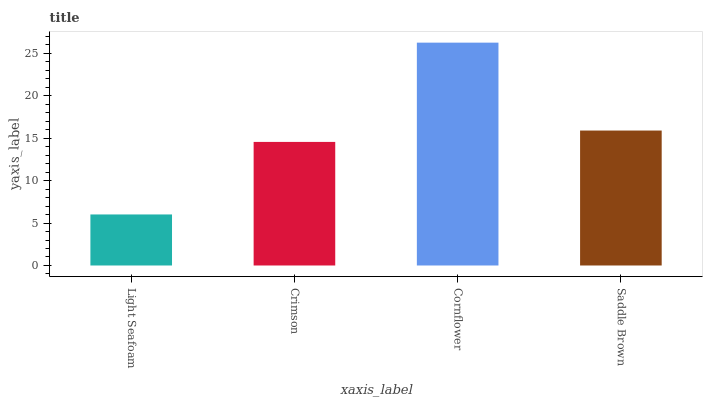Is Light Seafoam the minimum?
Answer yes or no. Yes. Is Cornflower the maximum?
Answer yes or no. Yes. Is Crimson the minimum?
Answer yes or no. No. Is Crimson the maximum?
Answer yes or no. No. Is Crimson greater than Light Seafoam?
Answer yes or no. Yes. Is Light Seafoam less than Crimson?
Answer yes or no. Yes. Is Light Seafoam greater than Crimson?
Answer yes or no. No. Is Crimson less than Light Seafoam?
Answer yes or no. No. Is Saddle Brown the high median?
Answer yes or no. Yes. Is Crimson the low median?
Answer yes or no. Yes. Is Light Seafoam the high median?
Answer yes or no. No. Is Cornflower the low median?
Answer yes or no. No. 